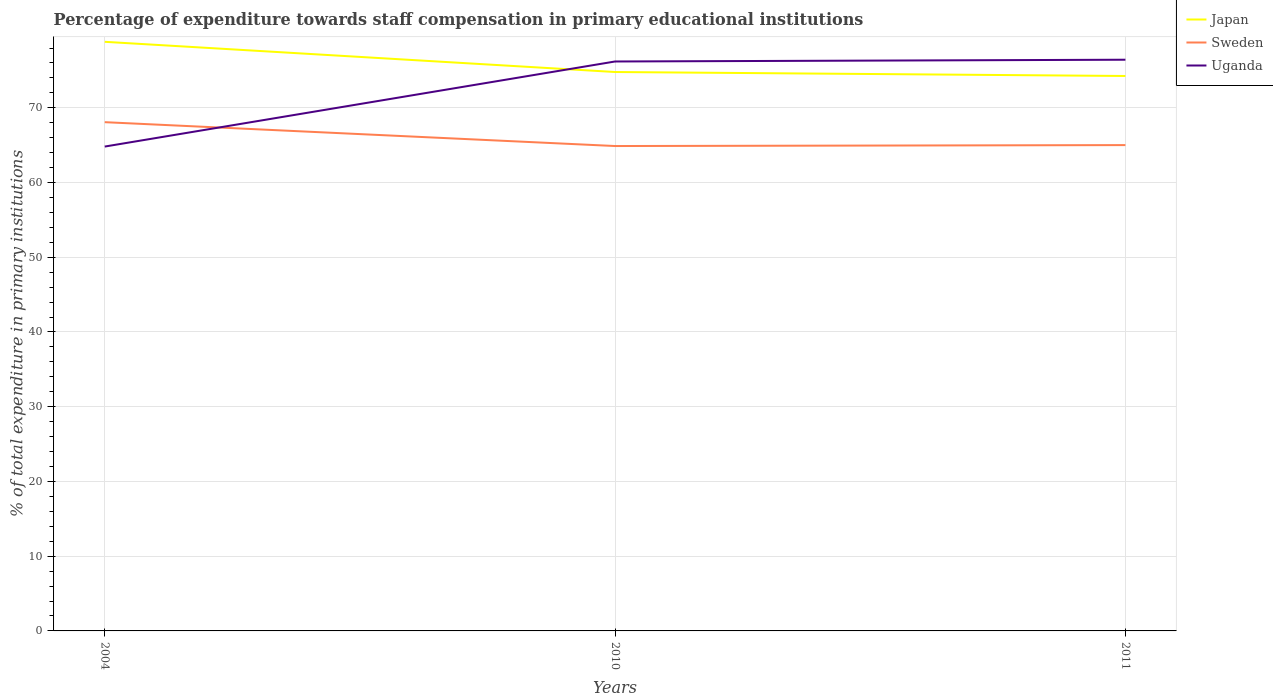How many different coloured lines are there?
Provide a succinct answer. 3. Across all years, what is the maximum percentage of expenditure towards staff compensation in Sweden?
Provide a succinct answer. 64.88. What is the total percentage of expenditure towards staff compensation in Sweden in the graph?
Your answer should be very brief. -0.13. What is the difference between the highest and the second highest percentage of expenditure towards staff compensation in Sweden?
Provide a short and direct response. 3.19. What is the difference between the highest and the lowest percentage of expenditure towards staff compensation in Uganda?
Make the answer very short. 2. How many lines are there?
Offer a terse response. 3. How many years are there in the graph?
Give a very brief answer. 3. What is the difference between two consecutive major ticks on the Y-axis?
Your answer should be very brief. 10. Are the values on the major ticks of Y-axis written in scientific E-notation?
Provide a succinct answer. No. Does the graph contain any zero values?
Make the answer very short. No. What is the title of the graph?
Your answer should be compact. Percentage of expenditure towards staff compensation in primary educational institutions. What is the label or title of the Y-axis?
Give a very brief answer. % of total expenditure in primary institutions. What is the % of total expenditure in primary institutions of Japan in 2004?
Provide a succinct answer. 78.83. What is the % of total expenditure in primary institutions of Sweden in 2004?
Make the answer very short. 68.07. What is the % of total expenditure in primary institutions in Uganda in 2004?
Make the answer very short. 64.81. What is the % of total expenditure in primary institutions of Japan in 2010?
Your answer should be very brief. 74.79. What is the % of total expenditure in primary institutions in Sweden in 2010?
Offer a very short reply. 64.88. What is the % of total expenditure in primary institutions of Uganda in 2010?
Make the answer very short. 76.2. What is the % of total expenditure in primary institutions of Japan in 2011?
Provide a short and direct response. 74.26. What is the % of total expenditure in primary institutions of Sweden in 2011?
Your answer should be compact. 65.01. What is the % of total expenditure in primary institutions in Uganda in 2011?
Make the answer very short. 76.43. Across all years, what is the maximum % of total expenditure in primary institutions in Japan?
Provide a short and direct response. 78.83. Across all years, what is the maximum % of total expenditure in primary institutions in Sweden?
Offer a terse response. 68.07. Across all years, what is the maximum % of total expenditure in primary institutions of Uganda?
Your answer should be very brief. 76.43. Across all years, what is the minimum % of total expenditure in primary institutions in Japan?
Provide a short and direct response. 74.26. Across all years, what is the minimum % of total expenditure in primary institutions of Sweden?
Your answer should be compact. 64.88. Across all years, what is the minimum % of total expenditure in primary institutions of Uganda?
Provide a succinct answer. 64.81. What is the total % of total expenditure in primary institutions in Japan in the graph?
Offer a terse response. 227.87. What is the total % of total expenditure in primary institutions in Sweden in the graph?
Offer a terse response. 197.97. What is the total % of total expenditure in primary institutions of Uganda in the graph?
Ensure brevity in your answer.  217.44. What is the difference between the % of total expenditure in primary institutions of Japan in 2004 and that in 2010?
Offer a very short reply. 4.04. What is the difference between the % of total expenditure in primary institutions of Sweden in 2004 and that in 2010?
Make the answer very short. 3.19. What is the difference between the % of total expenditure in primary institutions in Uganda in 2004 and that in 2010?
Offer a very short reply. -11.38. What is the difference between the % of total expenditure in primary institutions in Japan in 2004 and that in 2011?
Give a very brief answer. 4.57. What is the difference between the % of total expenditure in primary institutions of Sweden in 2004 and that in 2011?
Your answer should be compact. 3.07. What is the difference between the % of total expenditure in primary institutions in Uganda in 2004 and that in 2011?
Offer a terse response. -11.62. What is the difference between the % of total expenditure in primary institutions in Japan in 2010 and that in 2011?
Offer a terse response. 0.53. What is the difference between the % of total expenditure in primary institutions in Sweden in 2010 and that in 2011?
Provide a short and direct response. -0.13. What is the difference between the % of total expenditure in primary institutions of Uganda in 2010 and that in 2011?
Provide a short and direct response. -0.24. What is the difference between the % of total expenditure in primary institutions of Japan in 2004 and the % of total expenditure in primary institutions of Sweden in 2010?
Offer a very short reply. 13.94. What is the difference between the % of total expenditure in primary institutions of Japan in 2004 and the % of total expenditure in primary institutions of Uganda in 2010?
Your answer should be very brief. 2.63. What is the difference between the % of total expenditure in primary institutions of Sweden in 2004 and the % of total expenditure in primary institutions of Uganda in 2010?
Offer a terse response. -8.12. What is the difference between the % of total expenditure in primary institutions in Japan in 2004 and the % of total expenditure in primary institutions in Sweden in 2011?
Your answer should be very brief. 13.82. What is the difference between the % of total expenditure in primary institutions in Japan in 2004 and the % of total expenditure in primary institutions in Uganda in 2011?
Offer a terse response. 2.4. What is the difference between the % of total expenditure in primary institutions in Sweden in 2004 and the % of total expenditure in primary institutions in Uganda in 2011?
Ensure brevity in your answer.  -8.36. What is the difference between the % of total expenditure in primary institutions in Japan in 2010 and the % of total expenditure in primary institutions in Sweden in 2011?
Make the answer very short. 9.78. What is the difference between the % of total expenditure in primary institutions in Japan in 2010 and the % of total expenditure in primary institutions in Uganda in 2011?
Offer a terse response. -1.65. What is the difference between the % of total expenditure in primary institutions in Sweden in 2010 and the % of total expenditure in primary institutions in Uganda in 2011?
Keep it short and to the point. -11.55. What is the average % of total expenditure in primary institutions in Japan per year?
Your answer should be very brief. 75.96. What is the average % of total expenditure in primary institutions of Sweden per year?
Offer a terse response. 65.99. What is the average % of total expenditure in primary institutions in Uganda per year?
Provide a short and direct response. 72.48. In the year 2004, what is the difference between the % of total expenditure in primary institutions in Japan and % of total expenditure in primary institutions in Sweden?
Ensure brevity in your answer.  10.75. In the year 2004, what is the difference between the % of total expenditure in primary institutions in Japan and % of total expenditure in primary institutions in Uganda?
Your response must be concise. 14.02. In the year 2004, what is the difference between the % of total expenditure in primary institutions of Sweden and % of total expenditure in primary institutions of Uganda?
Keep it short and to the point. 3.26. In the year 2010, what is the difference between the % of total expenditure in primary institutions in Japan and % of total expenditure in primary institutions in Sweden?
Make the answer very short. 9.9. In the year 2010, what is the difference between the % of total expenditure in primary institutions of Japan and % of total expenditure in primary institutions of Uganda?
Your answer should be very brief. -1.41. In the year 2010, what is the difference between the % of total expenditure in primary institutions in Sweden and % of total expenditure in primary institutions in Uganda?
Make the answer very short. -11.31. In the year 2011, what is the difference between the % of total expenditure in primary institutions in Japan and % of total expenditure in primary institutions in Sweden?
Give a very brief answer. 9.25. In the year 2011, what is the difference between the % of total expenditure in primary institutions of Japan and % of total expenditure in primary institutions of Uganda?
Keep it short and to the point. -2.18. In the year 2011, what is the difference between the % of total expenditure in primary institutions in Sweden and % of total expenditure in primary institutions in Uganda?
Make the answer very short. -11.42. What is the ratio of the % of total expenditure in primary institutions in Japan in 2004 to that in 2010?
Give a very brief answer. 1.05. What is the ratio of the % of total expenditure in primary institutions of Sweden in 2004 to that in 2010?
Offer a terse response. 1.05. What is the ratio of the % of total expenditure in primary institutions in Uganda in 2004 to that in 2010?
Your answer should be compact. 0.85. What is the ratio of the % of total expenditure in primary institutions of Japan in 2004 to that in 2011?
Make the answer very short. 1.06. What is the ratio of the % of total expenditure in primary institutions of Sweden in 2004 to that in 2011?
Your answer should be compact. 1.05. What is the ratio of the % of total expenditure in primary institutions of Uganda in 2004 to that in 2011?
Keep it short and to the point. 0.85. What is the ratio of the % of total expenditure in primary institutions in Japan in 2010 to that in 2011?
Offer a terse response. 1.01. What is the difference between the highest and the second highest % of total expenditure in primary institutions of Japan?
Your answer should be very brief. 4.04. What is the difference between the highest and the second highest % of total expenditure in primary institutions in Sweden?
Provide a short and direct response. 3.07. What is the difference between the highest and the second highest % of total expenditure in primary institutions in Uganda?
Your response must be concise. 0.24. What is the difference between the highest and the lowest % of total expenditure in primary institutions in Japan?
Ensure brevity in your answer.  4.57. What is the difference between the highest and the lowest % of total expenditure in primary institutions in Sweden?
Keep it short and to the point. 3.19. What is the difference between the highest and the lowest % of total expenditure in primary institutions in Uganda?
Keep it short and to the point. 11.62. 